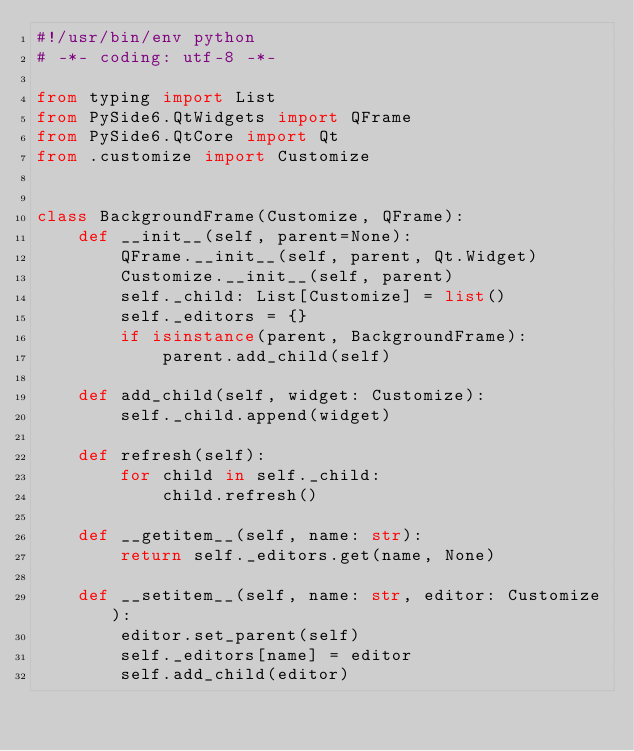<code> <loc_0><loc_0><loc_500><loc_500><_Python_>#!/usr/bin/env python
# -*- coding: utf-8 -*-

from typing import List
from PySide6.QtWidgets import QFrame
from PySide6.QtCore import Qt
from .customize import Customize


class BackgroundFrame(Customize, QFrame):
    def __init__(self, parent=None):
        QFrame.__init__(self, parent, Qt.Widget)
        Customize.__init__(self, parent)
        self._child: List[Customize] = list()
        self._editors = {}
        if isinstance(parent, BackgroundFrame):
            parent.add_child(self)

    def add_child(self, widget: Customize):
        self._child.append(widget)

    def refresh(self):
        for child in self._child:
            child.refresh()

    def __getitem__(self, name: str):
        return self._editors.get(name, None)

    def __setitem__(self, name: str, editor: Customize):
        editor.set_parent(self)
        self._editors[name] = editor
        self.add_child(editor)
</code> 